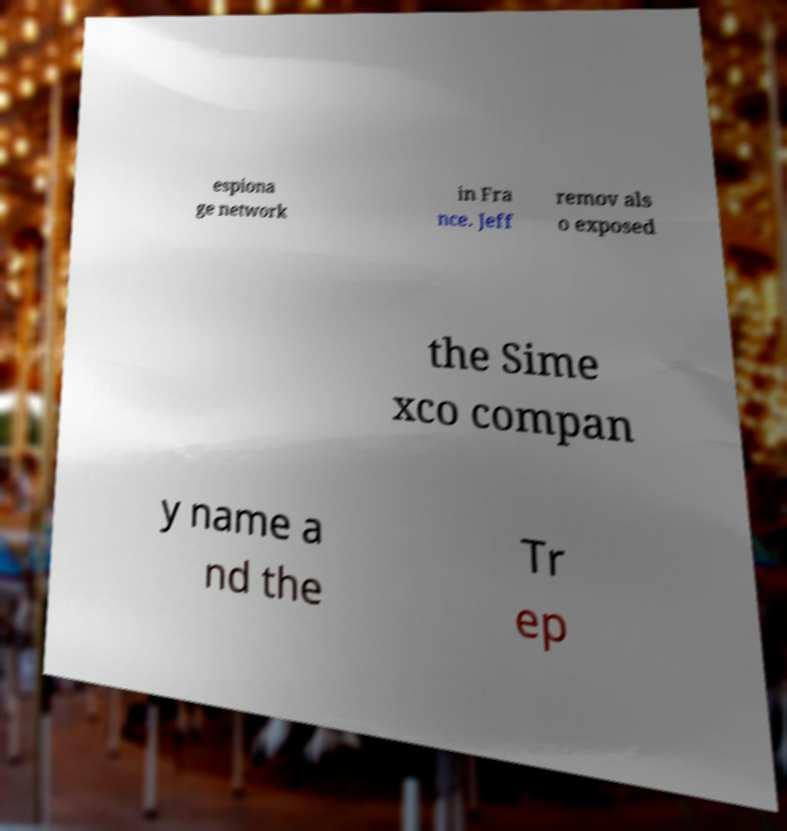Can you read and provide the text displayed in the image?This photo seems to have some interesting text. Can you extract and type it out for me? espiona ge network in Fra nce. Jeff remov als o exposed the Sime xco compan y name a nd the Tr ep 